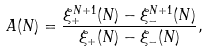Convert formula to latex. <formula><loc_0><loc_0><loc_500><loc_500>A ( N ) = \frac { \xi _ { + } ^ { N + 1 } ( N ) - \xi _ { - } ^ { N + 1 } ( N ) } { \xi _ { + } ( N ) - \xi _ { - } ( N ) } ,</formula> 